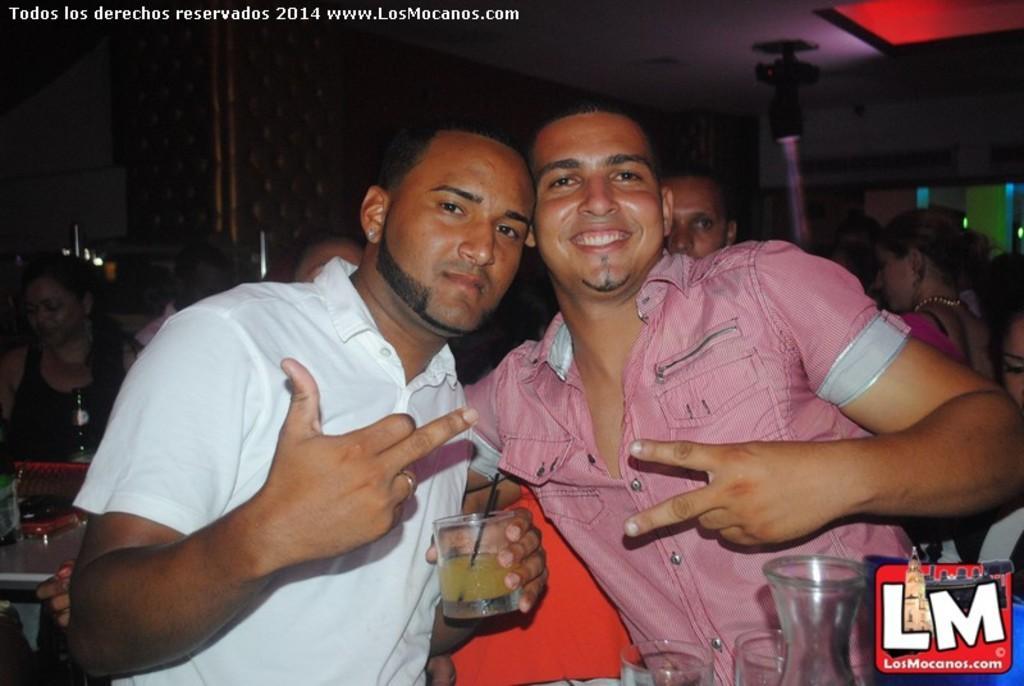Could you give a brief overview of what you see in this image? In this image we can see few people in a room, a person is holding a glass and some juice on it, there are some glasses. 